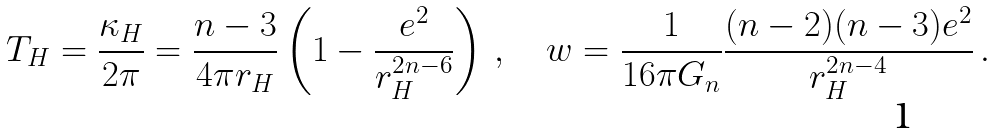Convert formula to latex. <formula><loc_0><loc_0><loc_500><loc_500>T _ { H } = \frac { \kappa _ { H } } { 2 \pi } = \frac { n - 3 } { 4 \pi r _ { H } } \left ( 1 - \frac { e ^ { 2 } } { r _ { H } ^ { 2 n - 6 } } \right ) \, , \quad w = \frac { 1 } { 1 6 \pi G _ { n } } \frac { ( n - 2 ) ( n - 3 ) e ^ { 2 } } { r _ { H } ^ { 2 n - 4 } } \, .</formula> 